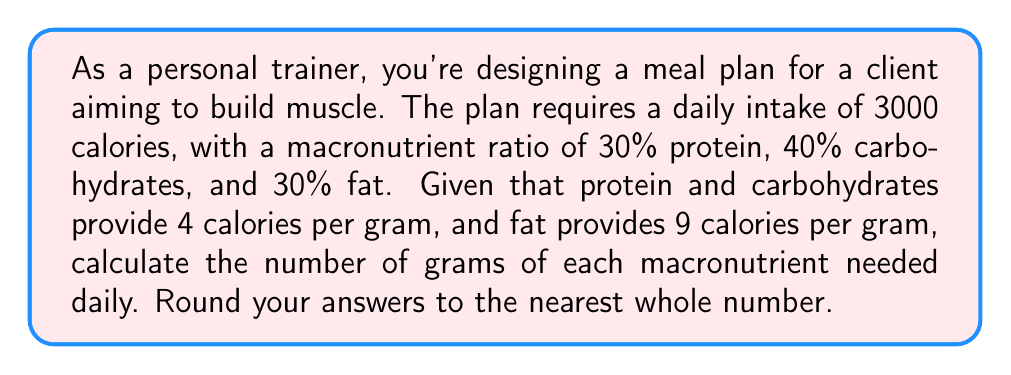What is the answer to this math problem? Let's break this down step-by-step:

1. Calculate the calories from each macronutrient:
   - Protein: $30\% \times 3000 = 900$ calories
   - Carbohydrates: $40\% \times 3000 = 1200$ calories
   - Fat: $30\% \times 3000 = 900$ calories

2. Convert calories to grams for protein:
   $$\text{Protein (g)} = \frac{900 \text{ calories}}{4 \text{ calories/g}} = 225 \text{ g}$$

3. Convert calories to grams for carbohydrates:
   $$\text{Carbohydrates (g)} = \frac{1200 \text{ calories}}{4 \text{ calories/g}} = 300 \text{ g}$$

4. Convert calories to grams for fat:
   $$\text{Fat (g)} = \frac{900 \text{ calories}}{9 \text{ calories/g}} = 100 \text{ g}$$

5. Round the results to the nearest whole number:
   - Protein: 225 g
   - Carbohydrates: 300 g
   - Fat: 100 g
Answer: Protein: 225 g, Carbohydrates: 300 g, Fat: 100 g 